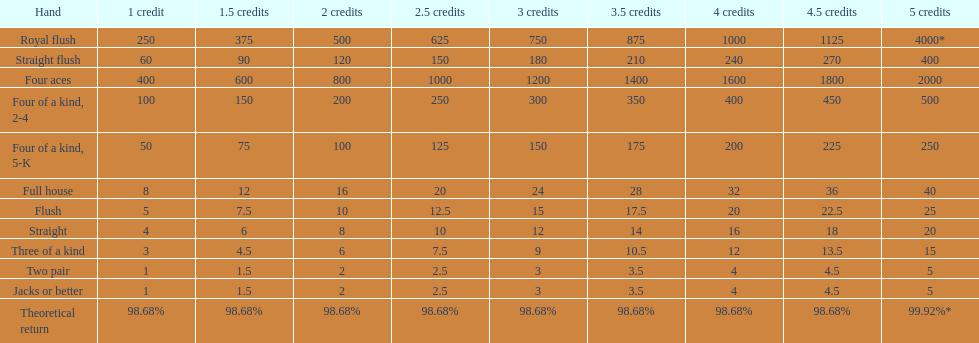Is a 2 credit full house the same as a 5 credit three of a kind? No. Can you give me this table as a dict? {'header': ['Hand', '1 credit', '1.5 credits', '2 credits', '2.5 credits', '3 credits', '3.5 credits', '4 credits', '4.5 credits', '5 credits'], 'rows': [['Royal flush', '250', '375', '500', '625', '750', '875', '1000', '1125', '4000*'], ['Straight flush', '60', '90', '120', '150', '180', '210', '240', '270', '400'], ['Four aces', '400', '600', '800', '1000', '1200', '1400', '1600', '1800', '2000'], ['Four of a kind, 2-4', '100', '150', '200', '250', '300', '350', '400', '450', '500'], ['Four of a kind, 5-K', '50', '75', '100', '125', '150', '175', '200', '225', '250'], ['Full house', '8', '12', '16', '20', '24', '28', '32', '36', '40'], ['Flush', '5', '7.5', '10', '12.5', '15', '17.5', '20', '22.5', '25'], ['Straight', '4', '6', '8', '10', '12', '14', '16', '18', '20'], ['Three of a kind', '3', '4.5', '6', '7.5', '9', '10.5', '12', '13.5', '15'], ['Two pair', '1', '1.5', '2', '2.5', '3', '3.5', '4', '4.5', '5'], ['Jacks or better', '1', '1.5', '2', '2.5', '3', '3.5', '4', '4.5', '5'], ['Theoretical return', '98.68%', '98.68%', '98.68%', '98.68%', '98.68%', '98.68%', '98.68%', '98.68%', '99.92%*']]} 